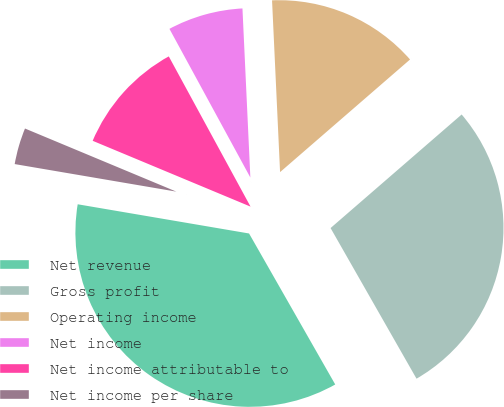<chart> <loc_0><loc_0><loc_500><loc_500><pie_chart><fcel>Net revenue<fcel>Gross profit<fcel>Operating income<fcel>Net income<fcel>Net income attributable to<fcel>Net income per share<nl><fcel>35.94%<fcel>28.11%<fcel>14.38%<fcel>7.19%<fcel>10.78%<fcel>3.6%<nl></chart> 